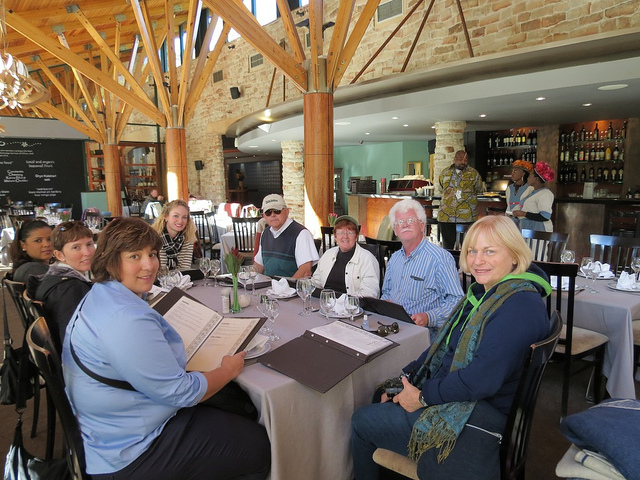How many dining tables are in the photo? There are two dining tables visible in the photo, each set up with plates and cutlery, suggesting that the diners are either expecting a meal soon or they have recently finished dining. 